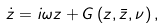Convert formula to latex. <formula><loc_0><loc_0><loc_500><loc_500>\dot { z } = i \omega z + G \left ( z , \bar { z } , \nu \right ) ,</formula> 